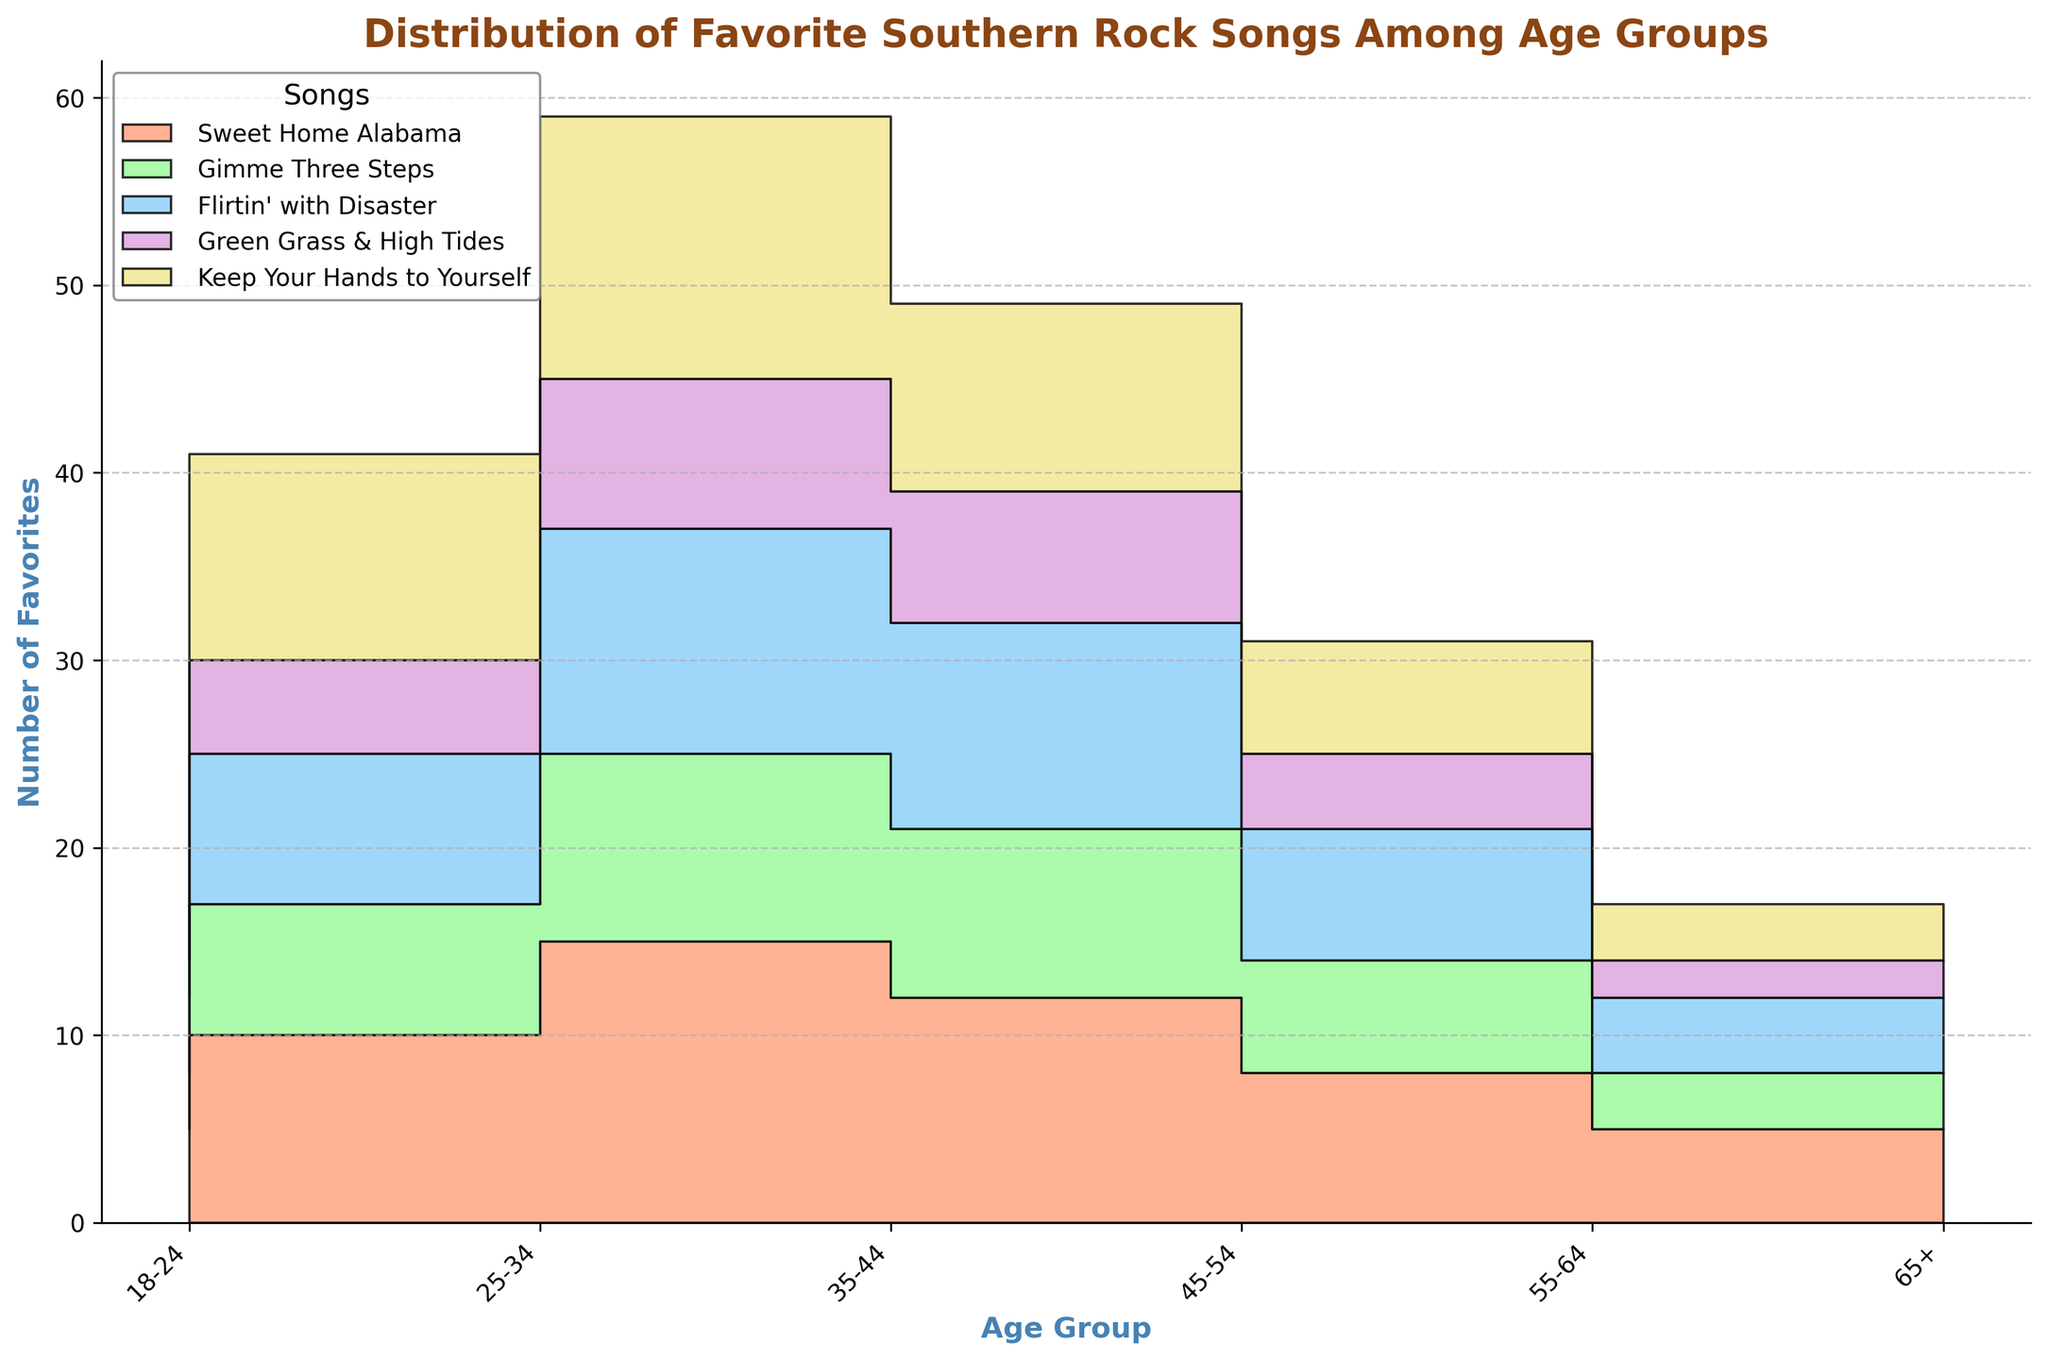Which song has the most favorites among the 35-44 age group? By observing the height of the step area for each song category, the "Keep Your Hands to Yourself" song has the highest area indicating the most favorites.
Answer: Keep Your Hands to Yourself What is the total number of favorites for the 18-24 age group? Sum up the number of favorites for all songs in the 18-24 age group: 5 (Sweet Home Alabama) + 3 (Gimme Three Steps) + 4 (Flirtin' with Disaster) + 2 (Green Grass & High Tides) + 6 (Keep Your Hands to Yourself) = 20.
Answer: 20 Which age group has the highest number of favorites for "Sweet Home Alabama"? By comparing the heights of the step areas for "Sweet Home Alabama" across age groups, the 35-44 age group has the highest height.
Answer: 35-44 How does the number of favorites for "Flirtin' with Disaster" change with the age groups? Observe the change in the step area for "Flirtin' with Disaster" across age groups: it increases from 18-24 to 35-44, peaks at 35-44, then decreases from 45-54 onwards.
Answer: Increases then decreases Which song has the fewest favorites among the 65+ age group? By comparing the heights of the step areas for each song category in the 65+ age group, "Green Grass & High Tides" has the lowest height.
Answer: Green Grass & High Tides What is the difference in the number of favorites for "Keep Your Hands to Yourself" between the 25-34 and 55-64 age groups? Subtract the favorites in the 55-64 age group from the 25-34 age group for "Keep Your Hands to Yourself": 11 (25-34) - 6 (55-64) = 5.
Answer: 5 